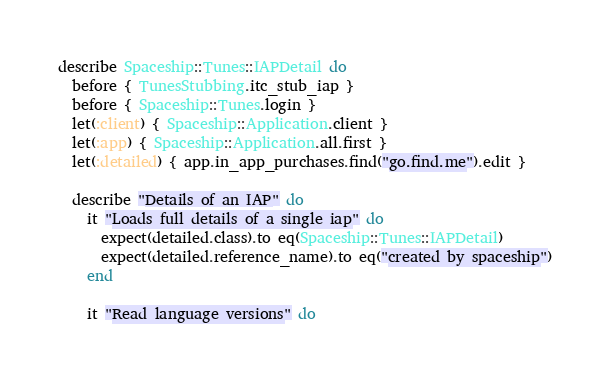Convert code to text. <code><loc_0><loc_0><loc_500><loc_500><_Ruby_>describe Spaceship::Tunes::IAPDetail do
  before { TunesStubbing.itc_stub_iap }
  before { Spaceship::Tunes.login }
  let(:client) { Spaceship::Application.client }
  let(:app) { Spaceship::Application.all.first }
  let(:detailed) { app.in_app_purchases.find("go.find.me").edit }

  describe "Details of an IAP" do
    it "Loads full details of a single iap" do
      expect(detailed.class).to eq(Spaceship::Tunes::IAPDetail)
      expect(detailed.reference_name).to eq("created by spaceship")
    end

    it "Read language versions" do</code> 